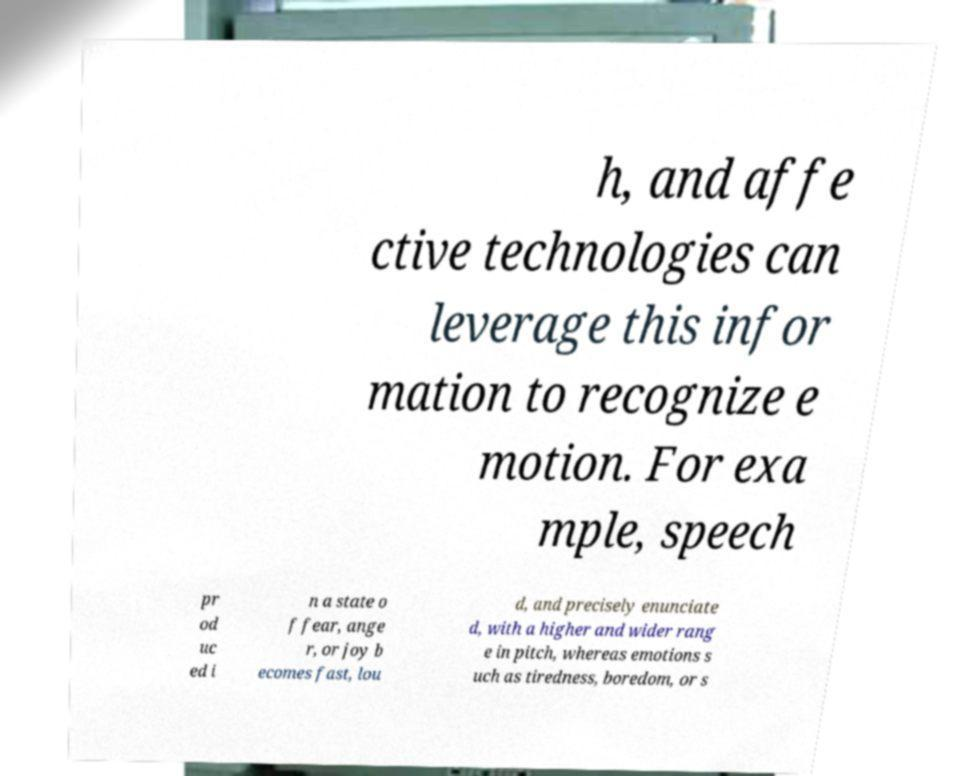I need the written content from this picture converted into text. Can you do that? h, and affe ctive technologies can leverage this infor mation to recognize e motion. For exa mple, speech pr od uc ed i n a state o f fear, ange r, or joy b ecomes fast, lou d, and precisely enunciate d, with a higher and wider rang e in pitch, whereas emotions s uch as tiredness, boredom, or s 